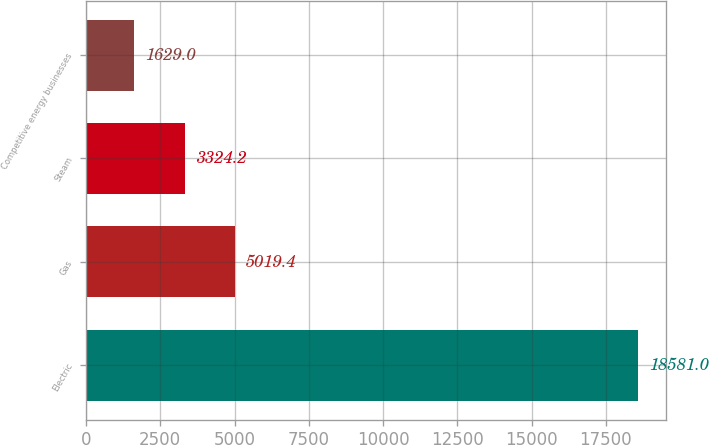<chart> <loc_0><loc_0><loc_500><loc_500><bar_chart><fcel>Electric<fcel>Gas<fcel>Steam<fcel>Competitive energy businesses<nl><fcel>18581<fcel>5019.4<fcel>3324.2<fcel>1629<nl></chart> 